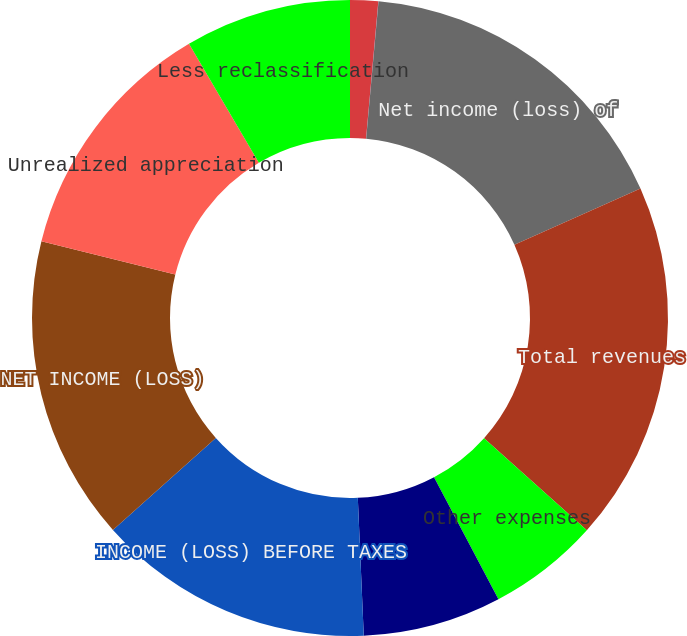Convert chart. <chart><loc_0><loc_0><loc_500><loc_500><pie_chart><fcel>Net investment income<fcel>Other income (expense)<fcel>Net income (loss) of<fcel>Total revenues<fcel>Other expenses<fcel>Total expenses<fcel>INCOME (LOSS) BEFORE TAXES<fcel>NET INCOME (LOSS)<fcel>Unrealized appreciation<fcel>Less reclassification<nl><fcel>1.42%<fcel>0.01%<fcel>16.9%<fcel>18.3%<fcel>5.64%<fcel>7.04%<fcel>14.08%<fcel>15.49%<fcel>12.67%<fcel>8.45%<nl></chart> 